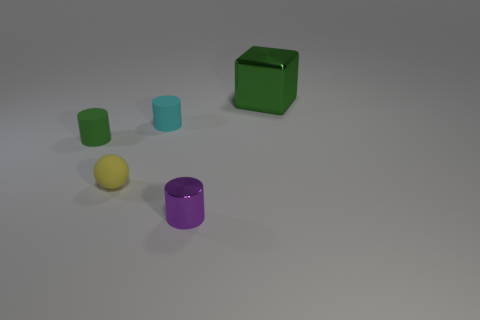Add 2 big gray cylinders. How many objects exist? 7 Subtract all matte cylinders. How many cylinders are left? 1 Subtract 0 yellow cubes. How many objects are left? 5 Subtract all cylinders. How many objects are left? 2 Subtract 1 cubes. How many cubes are left? 0 Subtract all brown cylinders. Subtract all gray spheres. How many cylinders are left? 3 Subtract all red balls. How many green cylinders are left? 1 Subtract all small purple metal things. Subtract all green rubber cylinders. How many objects are left? 3 Add 1 small yellow rubber spheres. How many small yellow rubber spheres are left? 2 Add 5 green metal things. How many green metal things exist? 6 